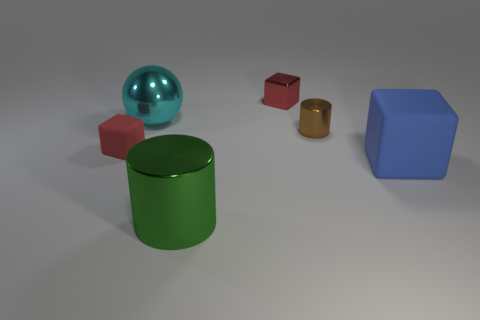Add 3 brown cylinders. How many objects exist? 9 Subtract all tiny metal blocks. How many blocks are left? 2 Subtract all balls. How many objects are left? 5 Subtract 2 blocks. How many blocks are left? 1 Subtract all brown cylinders. Subtract all brown blocks. How many cylinders are left? 1 Subtract all yellow cubes. How many yellow spheres are left? 0 Subtract all brown shiny cylinders. Subtract all small brown blocks. How many objects are left? 5 Add 3 small rubber objects. How many small rubber objects are left? 4 Add 2 large red matte things. How many large red matte things exist? 2 Subtract all brown cylinders. How many cylinders are left? 1 